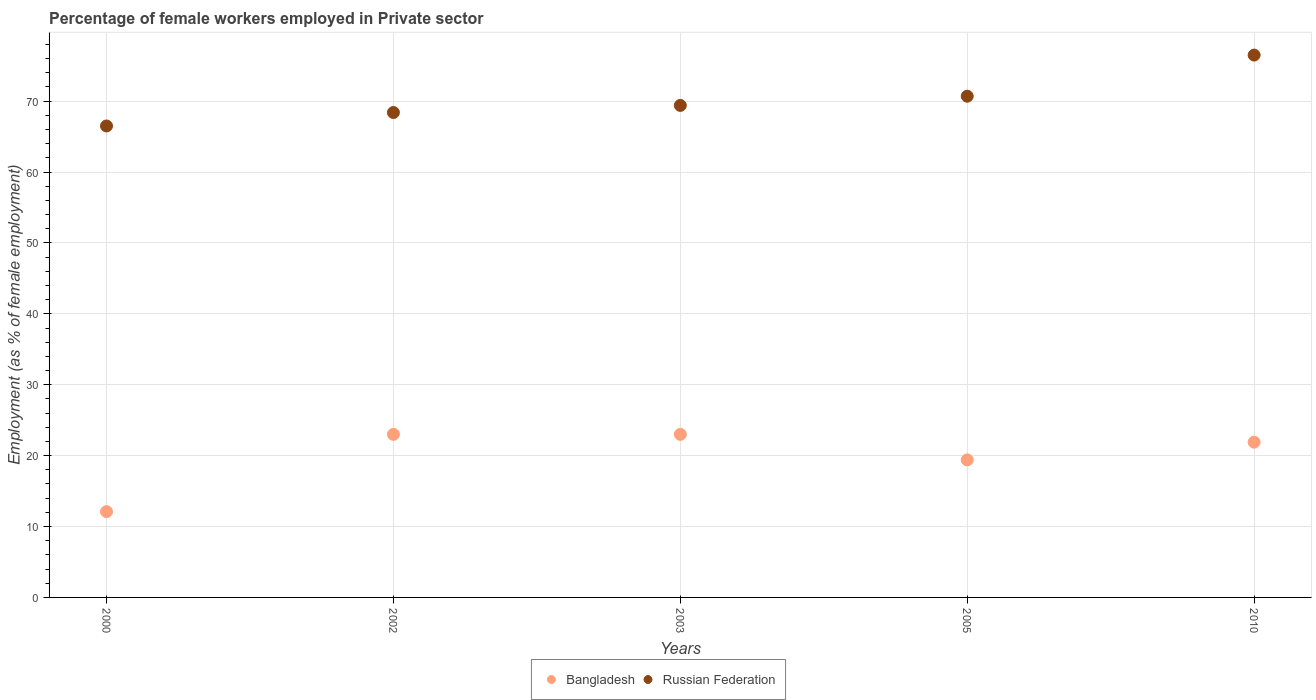Is the number of dotlines equal to the number of legend labels?
Offer a very short reply. Yes. What is the percentage of females employed in Private sector in Bangladesh in 2010?
Make the answer very short. 21.9. Across all years, what is the maximum percentage of females employed in Private sector in Russian Federation?
Your response must be concise. 76.5. Across all years, what is the minimum percentage of females employed in Private sector in Russian Federation?
Provide a succinct answer. 66.5. In which year was the percentage of females employed in Private sector in Russian Federation maximum?
Provide a short and direct response. 2010. In which year was the percentage of females employed in Private sector in Russian Federation minimum?
Your answer should be compact. 2000. What is the total percentage of females employed in Private sector in Bangladesh in the graph?
Provide a succinct answer. 99.4. What is the difference between the percentage of females employed in Private sector in Bangladesh in 2000 and that in 2010?
Offer a terse response. -9.8. What is the difference between the percentage of females employed in Private sector in Russian Federation in 2002 and the percentage of females employed in Private sector in Bangladesh in 2000?
Offer a terse response. 56.3. What is the average percentage of females employed in Private sector in Bangladesh per year?
Offer a terse response. 19.88. In the year 2002, what is the difference between the percentage of females employed in Private sector in Russian Federation and percentage of females employed in Private sector in Bangladesh?
Your response must be concise. 45.4. In how many years, is the percentage of females employed in Private sector in Bangladesh greater than 60 %?
Keep it short and to the point. 0. What is the ratio of the percentage of females employed in Private sector in Bangladesh in 2000 to that in 2010?
Your answer should be very brief. 0.55. What is the difference between the highest and the second highest percentage of females employed in Private sector in Russian Federation?
Keep it short and to the point. 5.8. What is the difference between the highest and the lowest percentage of females employed in Private sector in Russian Federation?
Provide a succinct answer. 10. Is the percentage of females employed in Private sector in Bangladesh strictly less than the percentage of females employed in Private sector in Russian Federation over the years?
Your answer should be very brief. Yes. Are the values on the major ticks of Y-axis written in scientific E-notation?
Make the answer very short. No. Does the graph contain any zero values?
Provide a succinct answer. No. Where does the legend appear in the graph?
Your answer should be very brief. Bottom center. How are the legend labels stacked?
Give a very brief answer. Horizontal. What is the title of the graph?
Give a very brief answer. Percentage of female workers employed in Private sector. What is the label or title of the Y-axis?
Ensure brevity in your answer.  Employment (as % of female employment). What is the Employment (as % of female employment) in Bangladesh in 2000?
Give a very brief answer. 12.1. What is the Employment (as % of female employment) of Russian Federation in 2000?
Ensure brevity in your answer.  66.5. What is the Employment (as % of female employment) of Bangladesh in 2002?
Your response must be concise. 23. What is the Employment (as % of female employment) of Russian Federation in 2002?
Your answer should be compact. 68.4. What is the Employment (as % of female employment) of Russian Federation in 2003?
Your answer should be compact. 69.4. What is the Employment (as % of female employment) of Bangladesh in 2005?
Make the answer very short. 19.4. What is the Employment (as % of female employment) of Russian Federation in 2005?
Ensure brevity in your answer.  70.7. What is the Employment (as % of female employment) in Bangladesh in 2010?
Your answer should be very brief. 21.9. What is the Employment (as % of female employment) of Russian Federation in 2010?
Your answer should be very brief. 76.5. Across all years, what is the maximum Employment (as % of female employment) in Bangladesh?
Keep it short and to the point. 23. Across all years, what is the maximum Employment (as % of female employment) in Russian Federation?
Your answer should be very brief. 76.5. Across all years, what is the minimum Employment (as % of female employment) of Bangladesh?
Your response must be concise. 12.1. Across all years, what is the minimum Employment (as % of female employment) of Russian Federation?
Your answer should be compact. 66.5. What is the total Employment (as % of female employment) of Bangladesh in the graph?
Keep it short and to the point. 99.4. What is the total Employment (as % of female employment) of Russian Federation in the graph?
Your response must be concise. 351.5. What is the difference between the Employment (as % of female employment) in Bangladesh in 2000 and that in 2002?
Keep it short and to the point. -10.9. What is the difference between the Employment (as % of female employment) in Russian Federation in 2000 and that in 2002?
Provide a short and direct response. -1.9. What is the difference between the Employment (as % of female employment) of Bangladesh in 2000 and that in 2003?
Ensure brevity in your answer.  -10.9. What is the difference between the Employment (as % of female employment) of Russian Federation in 2000 and that in 2003?
Offer a terse response. -2.9. What is the difference between the Employment (as % of female employment) in Bangladesh in 2000 and that in 2005?
Provide a short and direct response. -7.3. What is the difference between the Employment (as % of female employment) in Bangladesh in 2000 and that in 2010?
Ensure brevity in your answer.  -9.8. What is the difference between the Employment (as % of female employment) in Bangladesh in 2002 and that in 2003?
Provide a succinct answer. 0. What is the difference between the Employment (as % of female employment) of Russian Federation in 2002 and that in 2003?
Offer a terse response. -1. What is the difference between the Employment (as % of female employment) in Bangladesh in 2003 and that in 2005?
Make the answer very short. 3.6. What is the difference between the Employment (as % of female employment) of Bangladesh in 2003 and that in 2010?
Your answer should be compact. 1.1. What is the difference between the Employment (as % of female employment) of Russian Federation in 2003 and that in 2010?
Ensure brevity in your answer.  -7.1. What is the difference between the Employment (as % of female employment) in Russian Federation in 2005 and that in 2010?
Provide a succinct answer. -5.8. What is the difference between the Employment (as % of female employment) in Bangladesh in 2000 and the Employment (as % of female employment) in Russian Federation in 2002?
Your answer should be compact. -56.3. What is the difference between the Employment (as % of female employment) in Bangladesh in 2000 and the Employment (as % of female employment) in Russian Federation in 2003?
Give a very brief answer. -57.3. What is the difference between the Employment (as % of female employment) in Bangladesh in 2000 and the Employment (as % of female employment) in Russian Federation in 2005?
Offer a very short reply. -58.6. What is the difference between the Employment (as % of female employment) in Bangladesh in 2000 and the Employment (as % of female employment) in Russian Federation in 2010?
Your answer should be compact. -64.4. What is the difference between the Employment (as % of female employment) of Bangladesh in 2002 and the Employment (as % of female employment) of Russian Federation in 2003?
Provide a succinct answer. -46.4. What is the difference between the Employment (as % of female employment) in Bangladesh in 2002 and the Employment (as % of female employment) in Russian Federation in 2005?
Provide a short and direct response. -47.7. What is the difference between the Employment (as % of female employment) in Bangladesh in 2002 and the Employment (as % of female employment) in Russian Federation in 2010?
Offer a terse response. -53.5. What is the difference between the Employment (as % of female employment) in Bangladesh in 2003 and the Employment (as % of female employment) in Russian Federation in 2005?
Offer a very short reply. -47.7. What is the difference between the Employment (as % of female employment) of Bangladesh in 2003 and the Employment (as % of female employment) of Russian Federation in 2010?
Offer a terse response. -53.5. What is the difference between the Employment (as % of female employment) in Bangladesh in 2005 and the Employment (as % of female employment) in Russian Federation in 2010?
Make the answer very short. -57.1. What is the average Employment (as % of female employment) of Bangladesh per year?
Your answer should be very brief. 19.88. What is the average Employment (as % of female employment) in Russian Federation per year?
Your answer should be compact. 70.3. In the year 2000, what is the difference between the Employment (as % of female employment) of Bangladesh and Employment (as % of female employment) of Russian Federation?
Give a very brief answer. -54.4. In the year 2002, what is the difference between the Employment (as % of female employment) of Bangladesh and Employment (as % of female employment) of Russian Federation?
Give a very brief answer. -45.4. In the year 2003, what is the difference between the Employment (as % of female employment) of Bangladesh and Employment (as % of female employment) of Russian Federation?
Your answer should be compact. -46.4. In the year 2005, what is the difference between the Employment (as % of female employment) in Bangladesh and Employment (as % of female employment) in Russian Federation?
Provide a short and direct response. -51.3. In the year 2010, what is the difference between the Employment (as % of female employment) in Bangladesh and Employment (as % of female employment) in Russian Federation?
Offer a terse response. -54.6. What is the ratio of the Employment (as % of female employment) in Bangladesh in 2000 to that in 2002?
Ensure brevity in your answer.  0.53. What is the ratio of the Employment (as % of female employment) in Russian Federation in 2000 to that in 2002?
Make the answer very short. 0.97. What is the ratio of the Employment (as % of female employment) of Bangladesh in 2000 to that in 2003?
Your answer should be compact. 0.53. What is the ratio of the Employment (as % of female employment) of Russian Federation in 2000 to that in 2003?
Provide a short and direct response. 0.96. What is the ratio of the Employment (as % of female employment) in Bangladesh in 2000 to that in 2005?
Ensure brevity in your answer.  0.62. What is the ratio of the Employment (as % of female employment) of Russian Federation in 2000 to that in 2005?
Offer a very short reply. 0.94. What is the ratio of the Employment (as % of female employment) of Bangladesh in 2000 to that in 2010?
Ensure brevity in your answer.  0.55. What is the ratio of the Employment (as % of female employment) in Russian Federation in 2000 to that in 2010?
Offer a terse response. 0.87. What is the ratio of the Employment (as % of female employment) in Russian Federation in 2002 to that in 2003?
Keep it short and to the point. 0.99. What is the ratio of the Employment (as % of female employment) in Bangladesh in 2002 to that in 2005?
Give a very brief answer. 1.19. What is the ratio of the Employment (as % of female employment) of Russian Federation in 2002 to that in 2005?
Provide a short and direct response. 0.97. What is the ratio of the Employment (as % of female employment) in Bangladesh in 2002 to that in 2010?
Offer a very short reply. 1.05. What is the ratio of the Employment (as % of female employment) of Russian Federation in 2002 to that in 2010?
Offer a very short reply. 0.89. What is the ratio of the Employment (as % of female employment) in Bangladesh in 2003 to that in 2005?
Ensure brevity in your answer.  1.19. What is the ratio of the Employment (as % of female employment) in Russian Federation in 2003 to that in 2005?
Provide a short and direct response. 0.98. What is the ratio of the Employment (as % of female employment) in Bangladesh in 2003 to that in 2010?
Your response must be concise. 1.05. What is the ratio of the Employment (as % of female employment) in Russian Federation in 2003 to that in 2010?
Keep it short and to the point. 0.91. What is the ratio of the Employment (as % of female employment) in Bangladesh in 2005 to that in 2010?
Give a very brief answer. 0.89. What is the ratio of the Employment (as % of female employment) of Russian Federation in 2005 to that in 2010?
Provide a short and direct response. 0.92. What is the difference between the highest and the lowest Employment (as % of female employment) in Russian Federation?
Your response must be concise. 10. 